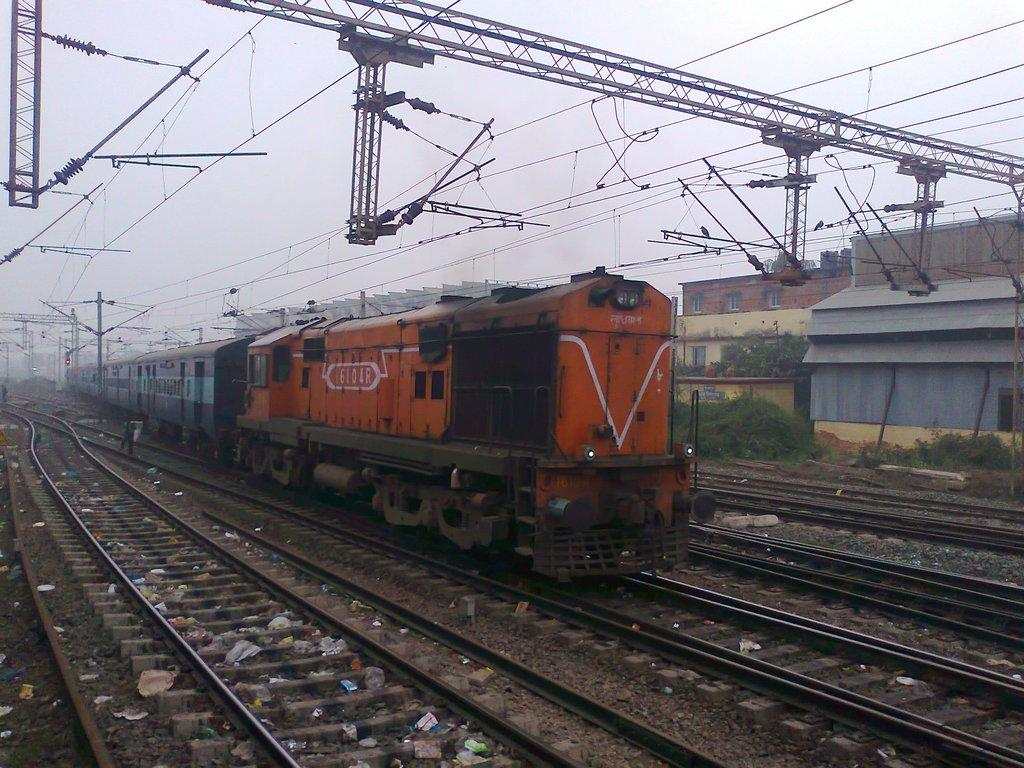What is the main subject of the image? The main subject of the image is a train on the track. What type of objects can be seen in the image besides the train? There are stones, poles, metal frames, plants, trees, buildings with windows, a traffic signal, and wires visible in the image. What is the natural environment like in the image? The natural environment includes plants and trees. What is visible in the sky in the image? The sky is visible in the image. What type of sound can be heard coming from the baby in the image? There is no baby present in the image, so no sound can be heard from a baby. 